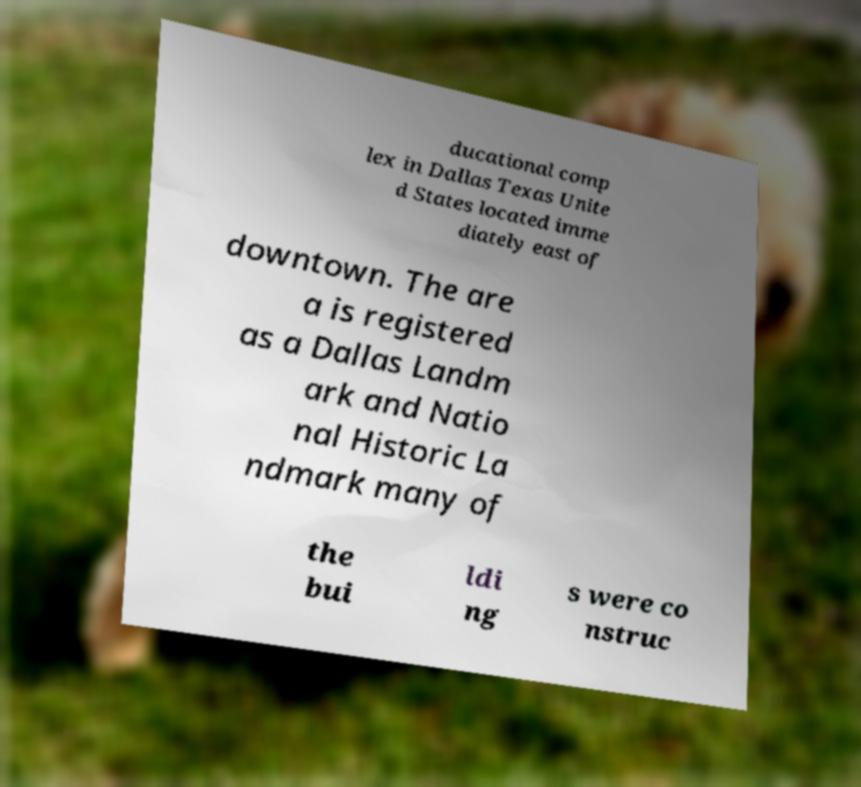Please read and relay the text visible in this image. What does it say? ducational comp lex in Dallas Texas Unite d States located imme diately east of downtown. The are a is registered as a Dallas Landm ark and Natio nal Historic La ndmark many of the bui ldi ng s were co nstruc 